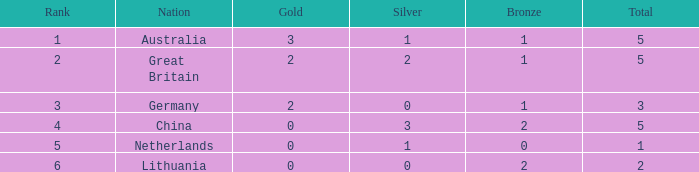What is the average Rank when there are 2 bronze, the total is 2 and gold is less than 0? None. 